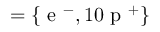Convert formula to latex. <formula><loc_0><loc_0><loc_500><loc_500>= \{ e ^ { - } , 1 0 p ^ { + } \}</formula> 